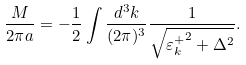Convert formula to latex. <formula><loc_0><loc_0><loc_500><loc_500>\frac { M } { 2 \pi a } = - \frac { 1 } { 2 } \int \frac { d ^ { 3 } k } { ( 2 \pi ) ^ { 3 } } \frac { 1 } { \sqrt { { \varepsilon _ { k } ^ { + } } ^ { 2 } + \Delta ^ { 2 } } } .</formula> 